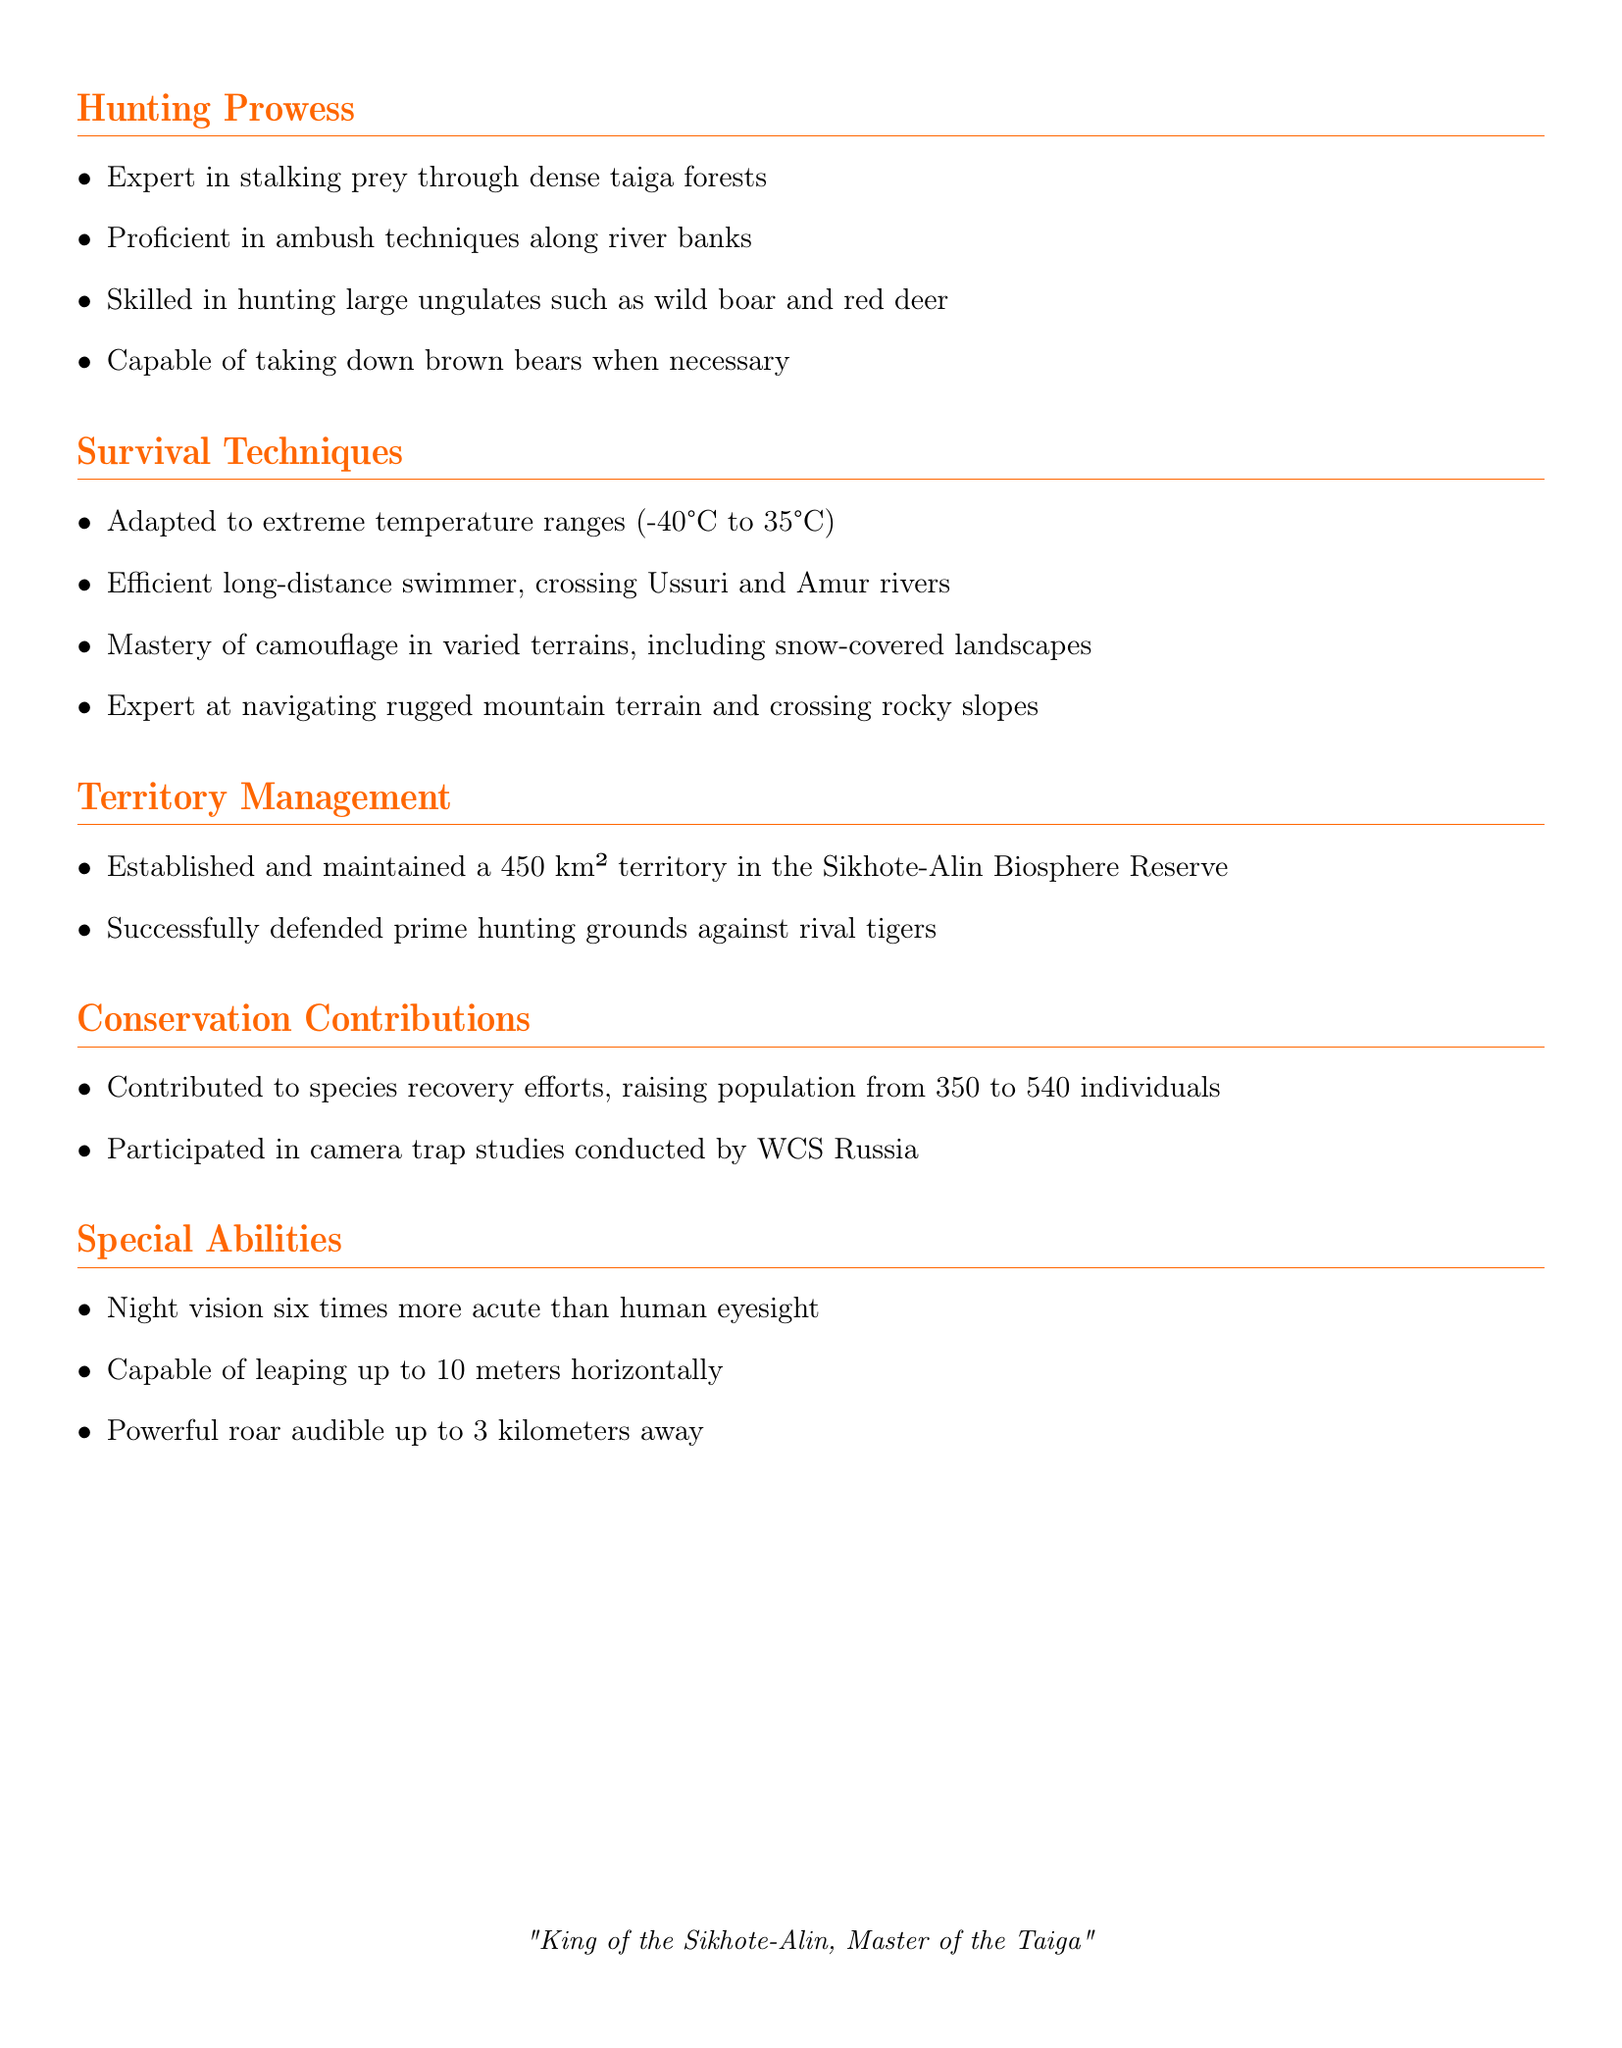What is the name of the tiger? The name provided in the document is listed at the top and indicates the identity of the individual.
Answer: Amur What species does Amur belong to? The species is specified under personal information and identifies the type of animal.
Answer: Siberian Tiger (Panthera tigris altaica) What is the size of Amur's territory? The size of the territory is given in the document, reflecting the area that Amur has established.
Answer: 450 km² How many individuals were raised through conservation efforts? The document mentions specific numbers related to conservation achievements, indicating how the population was impacted.
Answer: 540 What is Amur's primary hunting technique? The document categorizes Amur's primary skills in hunting, highlighting a key strategy for predation.
Answer: Stalking prey What extreme temperature range can Amur adapt to? The survival techniques section specifies the range of temperatures that Amur can handle, which showcases resilience.
Answer: -40°C to 35°C How far can Amur's roar be heard? The special abilities section provides specific detail about sound capabilities, illustrating the impressive nature of Amur's vocalizations.
Answer: 3 kilometers What activity did Amur participate in for conservation? The document includes activities that indicate involvement in conservation methodological approaches.
Answer: Camera trap studies What skill allows Amur to navigate the terrain effectively? The document lists specific skills under survival techniques, explaining the ability to move through challenging environments.
Answer: Mastery of camouflage What type of ungulates is Amur skilled at hunting? The hunting skills section specifies the types of animals that Amur targets, indicating proficiency in certain prey.
Answer: Wild boar and red deer 